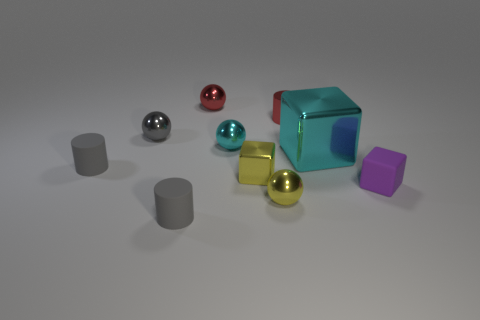How many matte things have the same color as the small metallic block? In the image, there is one small metallic block with a turquoise color, and there are no matte objects sharing that same color; all the matte objects present have different colors. 